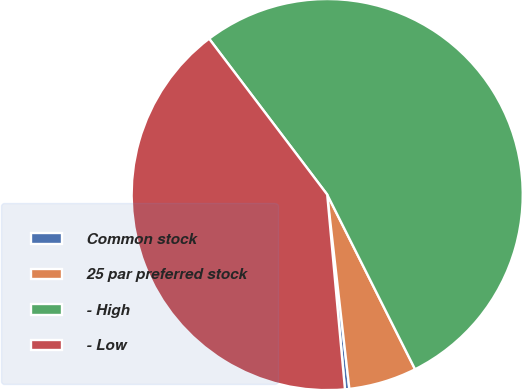Convert chart to OTSL. <chart><loc_0><loc_0><loc_500><loc_500><pie_chart><fcel>Common stock<fcel>25 par preferred stock<fcel>- High<fcel>- Low<nl><fcel>0.36%<fcel>5.61%<fcel>52.9%<fcel>41.13%<nl></chart> 